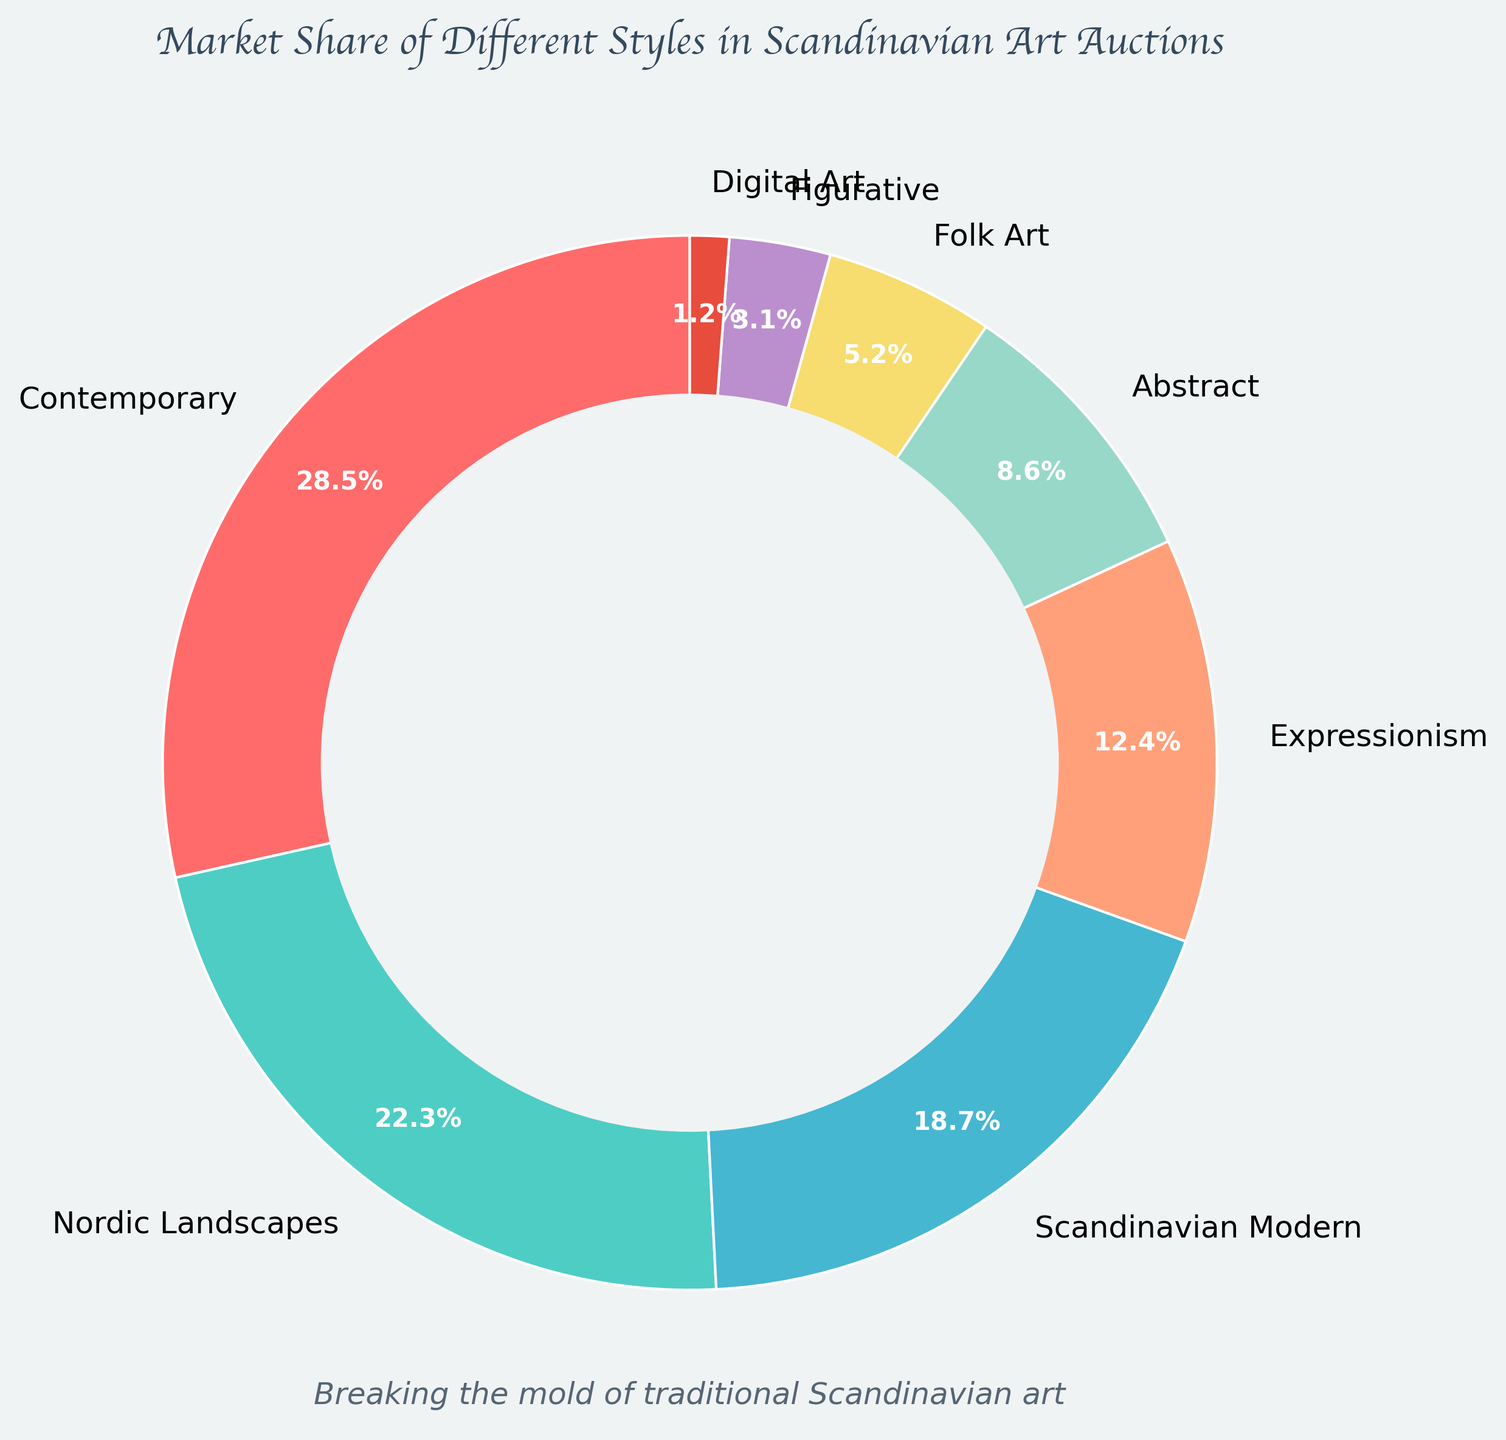What style occupies the largest market share in Scandinavian art auctions? The style with the highest percentage in the pie chart represents the largest market share. Contemporary art holds 28.5%, which is the highest among all styles.
Answer: Contemporary Which two styles combined have a market share of exactly 27.3%? By examining the market shares, Abstract (8.6%) and Folk Art (5.2%) add up to 13.8%. However, Expressionism (12.4%) and Scandinavian Modern (18.7%) add up to 31.1% and so forth. Only Expressionism (12.4%) and Folk Art (5.2%) combine to 27.3%.
Answer: Expressionism and Folk Art Which styles occupy less than 10% of the market share? Looking at the pie chart, Abstract (8.6%), Folk Art (5.2%), Figurative (3.1%), and Digital Art (1.2%) all have market shares less than 10%.
Answer: Abstract, Folk Art, Figurative, Digital Art Is the market share of Nordic Landscapes greater than that of the combined share of Abstract and Folk Art? Nordic Landscapes has 22.3%. Combined market share of Abstract (8.6%) and Folk Art (5.2%) is 13.8%. Since 22.3% is greater than 13.8%, the market share of Nordic Landscapes is greater.
Answer: Yes What is the difference in market share between Contemporary and Figurative art? Contemporary art has a market share of 28.5%, and Figurative art has 3.1%. The difference is 28.5% - 3.1% = 25.4%.
Answer: 25.4% How much larger is the market share of Scandinavian Modern compared to Digital Art? Scandinavian Modern has a market share of 18.7%, and Digital Art has 1.2%. The difference is 18.7% - 1.2% = 17.5%.
Answer: 17.5% Which style has the smallest market share, and what is its percentage? The smallest wedge in the pie chart represents Digital Art, which has a market share of 1.2%.
Answer: Digital Art, 1.2% What is the sum of the market shares of the three styles with the largest market shares? The three styles with the largest market shares are Contemporary (28.5%), Nordic Landscapes (22.3%), and Scandinavian Modern (18.7%). The sum is 28.5% + 22.3% + 18.7% = 69.5%.
Answer: 69.5% Among the styles with more than 20% market share, which one has lesser proportion? Only Contemporary (28.5%) and Nordic Landscapes (22.3%) have more than 20% market share. Nordic Landscapes has less proportion.
Answer: Nordic Landscapes 